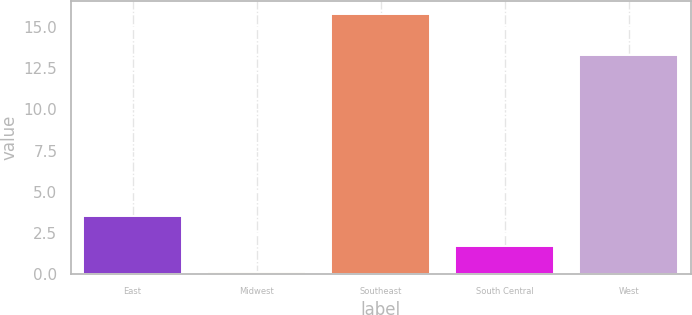<chart> <loc_0><loc_0><loc_500><loc_500><bar_chart><fcel>East<fcel>Midwest<fcel>Southeast<fcel>South Central<fcel>West<nl><fcel>3.5<fcel>0.1<fcel>15.8<fcel>1.67<fcel>13.3<nl></chart> 